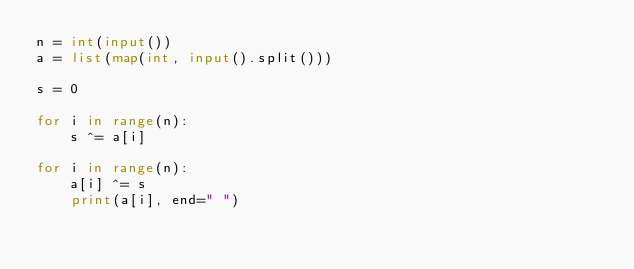Convert code to text. <code><loc_0><loc_0><loc_500><loc_500><_Python_>n = int(input())
a = list(map(int, input().split()))

s = 0

for i in range(n):
    s ^= a[i]

for i in range(n):
    a[i] ^= s
    print(a[i], end=" ")

</code> 